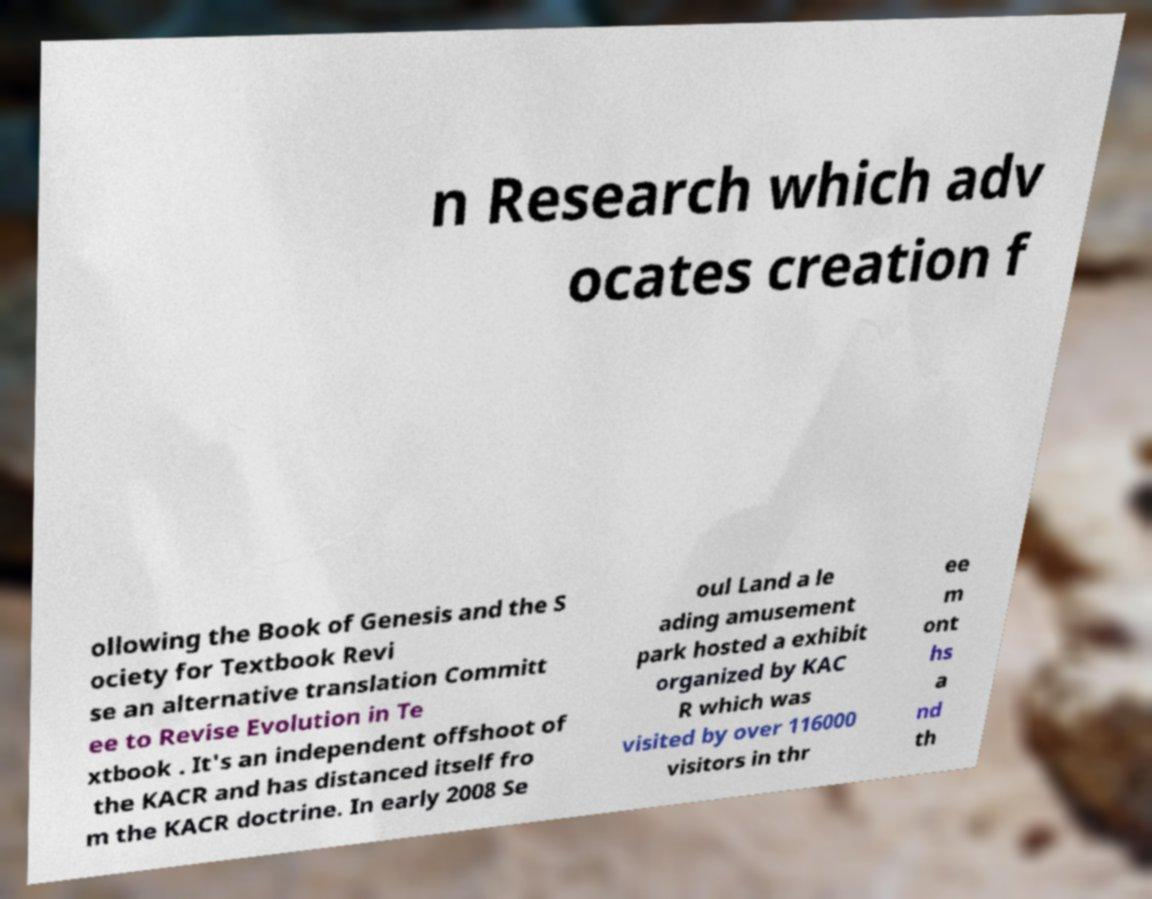Could you assist in decoding the text presented in this image and type it out clearly? n Research which adv ocates creation f ollowing the Book of Genesis and the S ociety for Textbook Revi se an alternative translation Committ ee to Revise Evolution in Te xtbook . It's an independent offshoot of the KACR and has distanced itself fro m the KACR doctrine. In early 2008 Se oul Land a le ading amusement park hosted a exhibit organized by KAC R which was visited by over 116000 visitors in thr ee m ont hs a nd th 